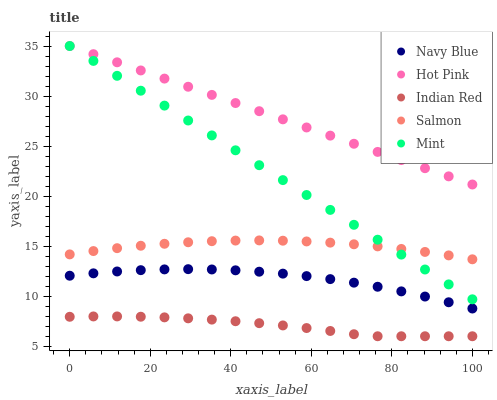Does Indian Red have the minimum area under the curve?
Answer yes or no. Yes. Does Hot Pink have the maximum area under the curve?
Answer yes or no. Yes. Does Salmon have the minimum area under the curve?
Answer yes or no. No. Does Salmon have the maximum area under the curve?
Answer yes or no. No. Is Hot Pink the smoothest?
Answer yes or no. Yes. Is Navy Blue the roughest?
Answer yes or no. Yes. Is Salmon the smoothest?
Answer yes or no. No. Is Salmon the roughest?
Answer yes or no. No. Does Indian Red have the lowest value?
Answer yes or no. Yes. Does Salmon have the lowest value?
Answer yes or no. No. Does Mint have the highest value?
Answer yes or no. Yes. Does Salmon have the highest value?
Answer yes or no. No. Is Salmon less than Hot Pink?
Answer yes or no. Yes. Is Navy Blue greater than Indian Red?
Answer yes or no. Yes. Does Salmon intersect Mint?
Answer yes or no. Yes. Is Salmon less than Mint?
Answer yes or no. No. Is Salmon greater than Mint?
Answer yes or no. No. Does Salmon intersect Hot Pink?
Answer yes or no. No. 